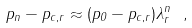Convert formula to latex. <formula><loc_0><loc_0><loc_500><loc_500>p _ { n } - p _ { c , r } \approx ( p _ { 0 } - p _ { c , r } ) \lambda _ { r } ^ { n } \ ,</formula> 